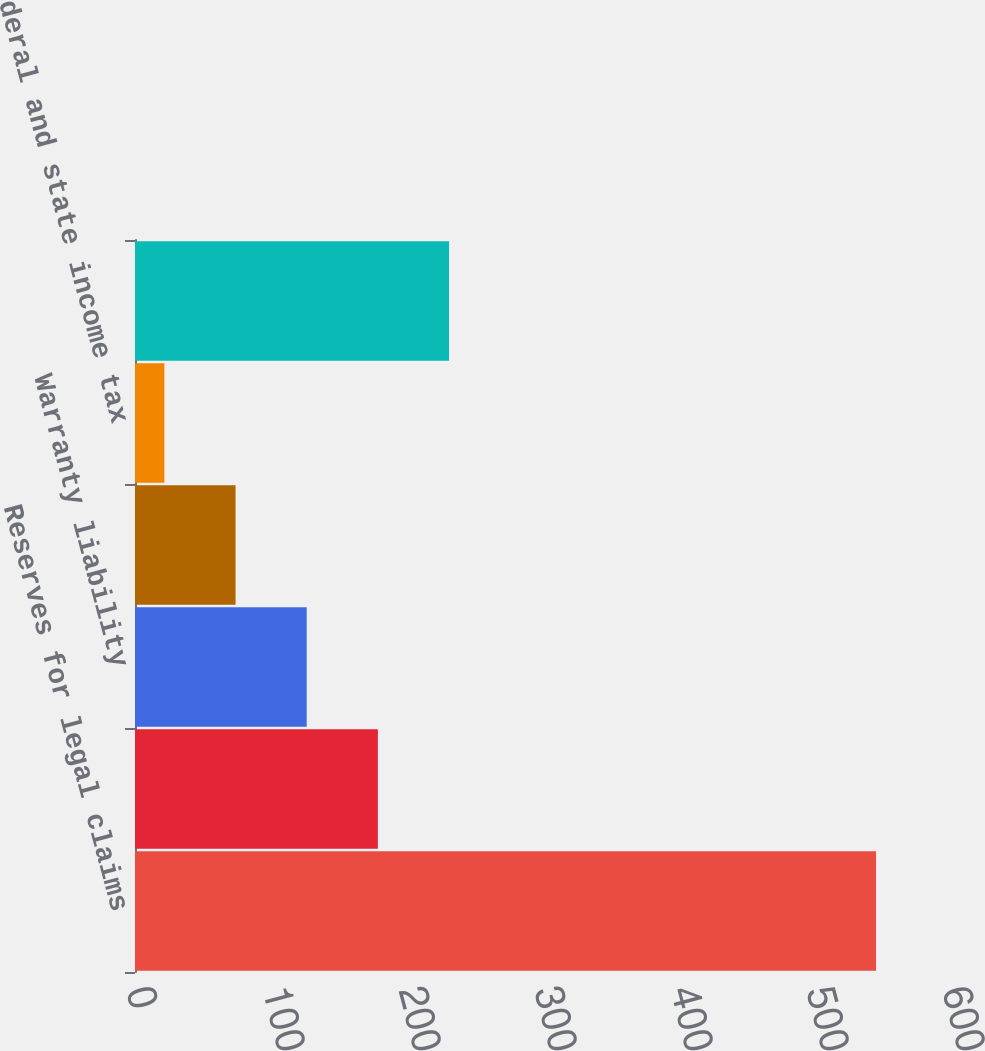Convert chart to OTSL. <chart><loc_0><loc_0><loc_500><loc_500><bar_chart><fcel>Reserves for legal claims<fcel>Employee compensation and<fcel>Warranty liability<fcel>Accrued interest<fcel>Federal and state income tax<fcel>Other liabilities<nl><fcel>544.9<fcel>178.59<fcel>126.26<fcel>73.93<fcel>21.6<fcel>230.92<nl></chart> 